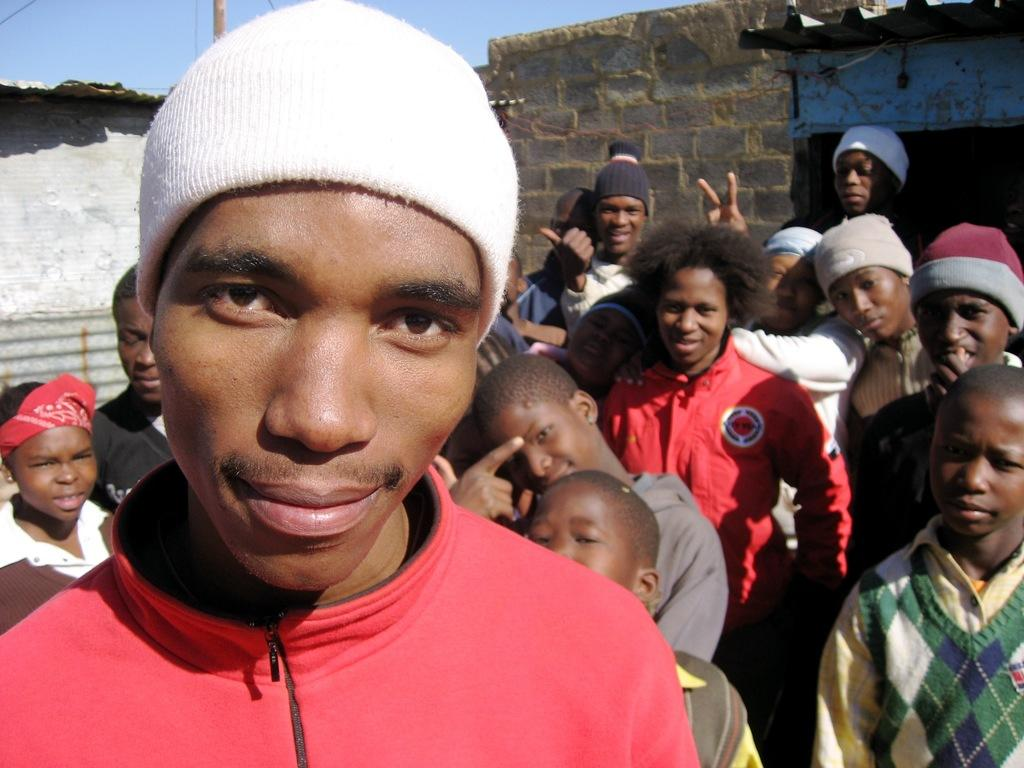How many people are in the image? There is a group of people standing in the image, but the exact number cannot be determined from the provided facts. What is located behind the people in the image? There are houses behind the people in the image. What can be seen attached to the pole in the image? There are cables attached to the pole in the image. What is visible in the background of the image? The sky is visible behind the houses in the image. How many clocks are hanging on the wall in the office depicted in the image? There is no office or wall with clocks present in the image. 